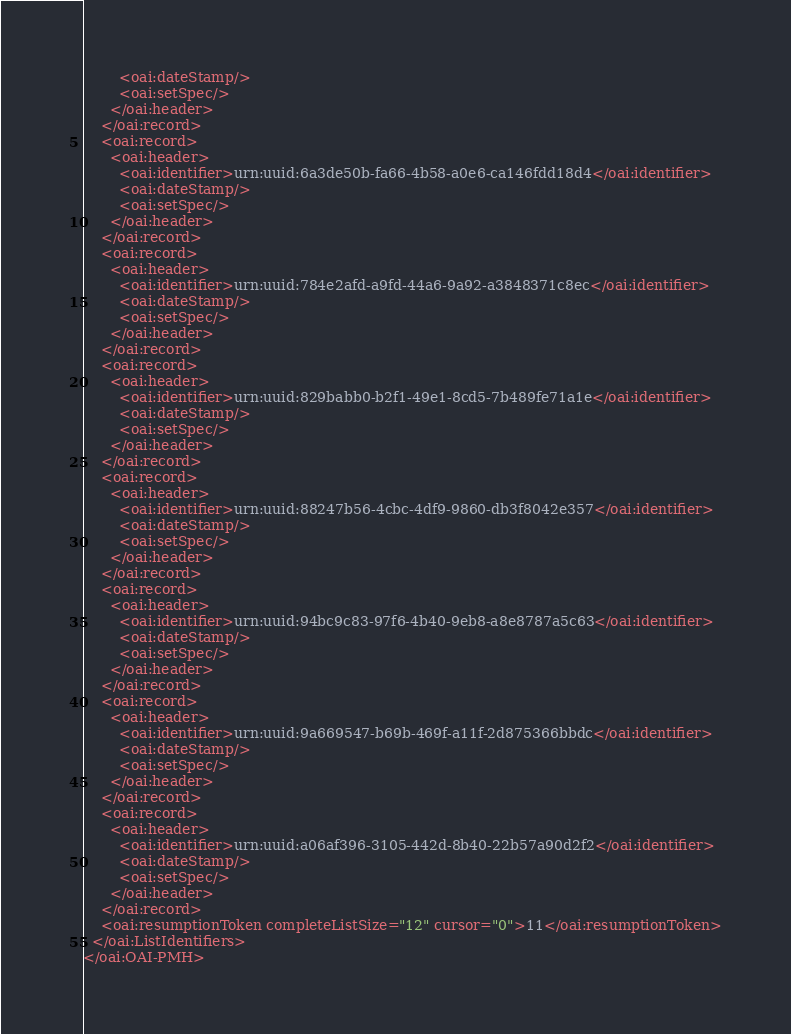<code> <loc_0><loc_0><loc_500><loc_500><_XML_>        <oai:dateStamp/>
        <oai:setSpec/>
      </oai:header>
    </oai:record>
    <oai:record>
      <oai:header>
        <oai:identifier>urn:uuid:6a3de50b-fa66-4b58-a0e6-ca146fdd18d4</oai:identifier>
        <oai:dateStamp/>
        <oai:setSpec/>
      </oai:header>
    </oai:record>
    <oai:record>
      <oai:header>
        <oai:identifier>urn:uuid:784e2afd-a9fd-44a6-9a92-a3848371c8ec</oai:identifier>
        <oai:dateStamp/>
        <oai:setSpec/>
      </oai:header>
    </oai:record>
    <oai:record>
      <oai:header>
        <oai:identifier>urn:uuid:829babb0-b2f1-49e1-8cd5-7b489fe71a1e</oai:identifier>
        <oai:dateStamp/>
        <oai:setSpec/>
      </oai:header>
    </oai:record>
    <oai:record>
      <oai:header>
        <oai:identifier>urn:uuid:88247b56-4cbc-4df9-9860-db3f8042e357</oai:identifier>
        <oai:dateStamp/>
        <oai:setSpec/>
      </oai:header>
    </oai:record>
    <oai:record>
      <oai:header>
        <oai:identifier>urn:uuid:94bc9c83-97f6-4b40-9eb8-a8e8787a5c63</oai:identifier>
        <oai:dateStamp/>
        <oai:setSpec/>
      </oai:header>
    </oai:record>
    <oai:record>
      <oai:header>
        <oai:identifier>urn:uuid:9a669547-b69b-469f-a11f-2d875366bbdc</oai:identifier>
        <oai:dateStamp/>
        <oai:setSpec/>
      </oai:header>
    </oai:record>
    <oai:record>
      <oai:header>
        <oai:identifier>urn:uuid:a06af396-3105-442d-8b40-22b57a90d2f2</oai:identifier>
        <oai:dateStamp/>
        <oai:setSpec/>
      </oai:header>
    </oai:record>
    <oai:resumptionToken completeListSize="12" cursor="0">11</oai:resumptionToken>
  </oai:ListIdentifiers>
</oai:OAI-PMH>
</code> 